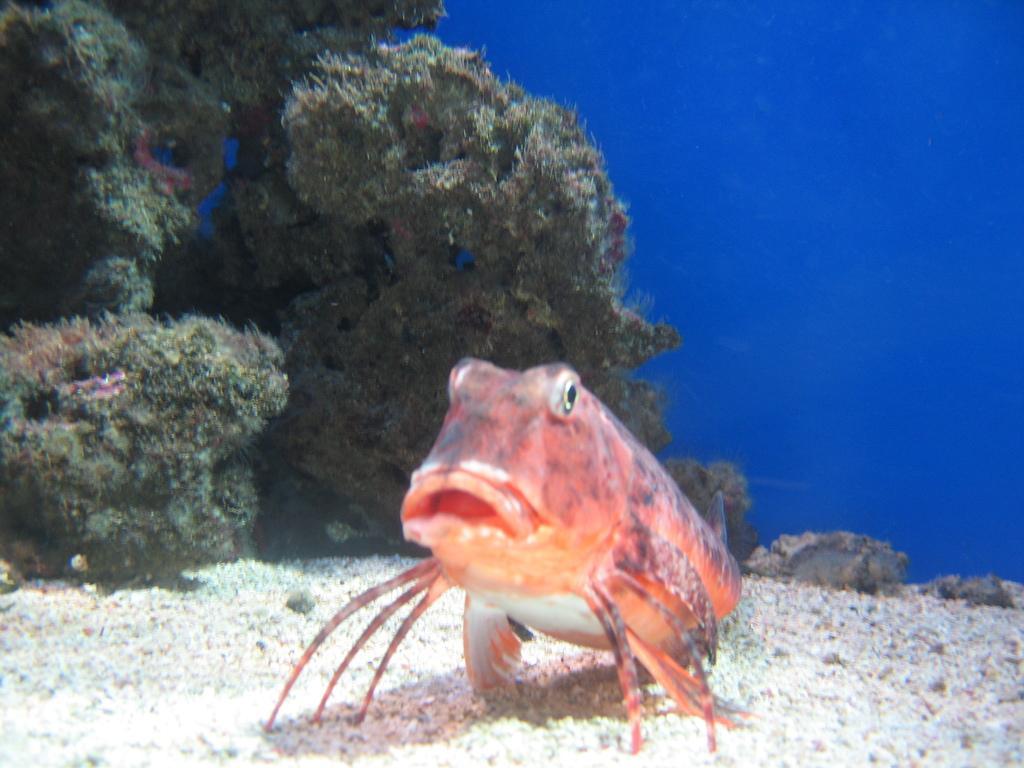Can you describe this image briefly? This picture might be taken in the water. In this image, in the middle, we can see a water mammal standing on the stone. In the background, we can see some trees and plants and rocks. On the right side, we can see blue color. 